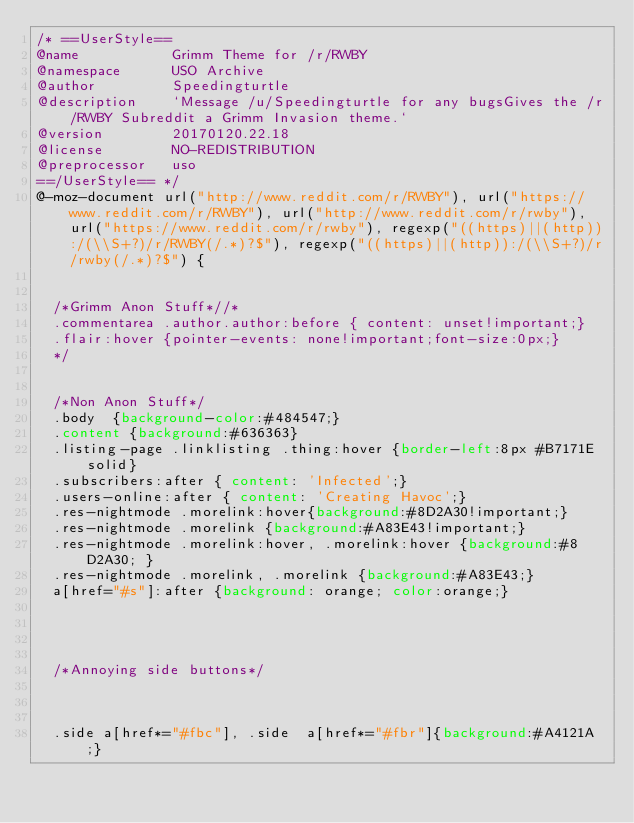<code> <loc_0><loc_0><loc_500><loc_500><_CSS_>/* ==UserStyle==
@name           Grimm Theme for /r/RWBY
@namespace      USO Archive
@author         Speedingturtle
@description    `Message /u/Speedingturtle for any bugsGives the /r/RWBY Subreddit a Grimm Invasion theme.`
@version        20170120.22.18
@license        NO-REDISTRIBUTION
@preprocessor   uso
==/UserStyle== */
@-moz-document url("http://www.reddit.com/r/RWBY"), url("https://www.reddit.com/r/RWBY"), url("http://www.reddit.com/r/rwby"), url("https://www.reddit.com/r/rwby"), regexp("((https)||(http)):/(\\S+?)/r/RWBY(/.*)?$"), regexp("((https)||(http)):/(\\S+?)/r/rwby(/.*)?$") {

  
  /*Grimm Anon Stuff*//*
  .commentarea .author.author:before { content: unset!important;}
  .flair:hover {pointer-events: none!important;font-size:0px;}
  */
  
  
  /*Non Anon Stuff*/
  .body  {background-color:#484547;}
  .content {background:#636363}
  .listing-page .linklisting .thing:hover {border-left:8px #B7171E solid}
  .subscribers:after { content: 'Infected';}
  .users-online:after { content: 'Creating Havoc';}
  .res-nightmode .morelink:hover{background:#8D2A30!important;}
  .res-nightmode .morelink {background:#A83E43!important;}
  .res-nightmode .morelink:hover, .morelink:hover {background:#8D2A30; }
  .res-nightmode .morelink, .morelink {background:#A83E43;}
  a[href="#s"]:after {background: orange; color:orange;}
  
  
  
  
  /*Annoying side buttons*/
  
  
  
  .side a[href*="#fbc"], .side  a[href*="#fbr"]{background:#A4121A;}</code> 